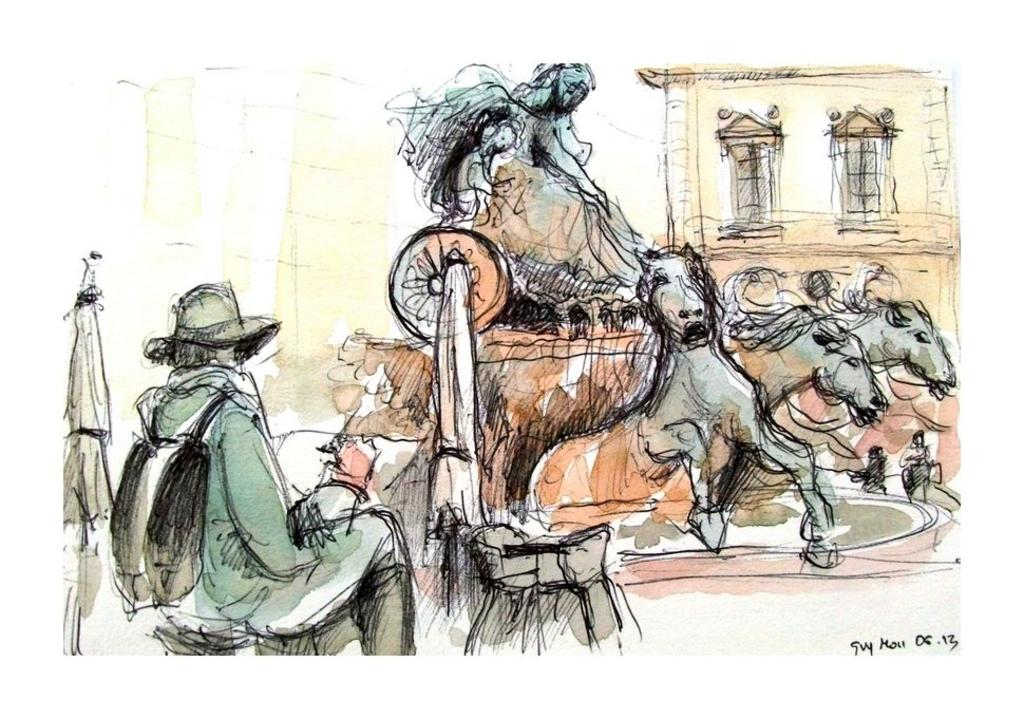What is present on the poster in the image? There is an art piece on the poster in the image. Can you see any bikes in the image? There are no bikes present in the image. What type of pleasure can be experienced from the art on the poster? The image does not provide information about the pleasure that can be experienced from the art on the poster. 